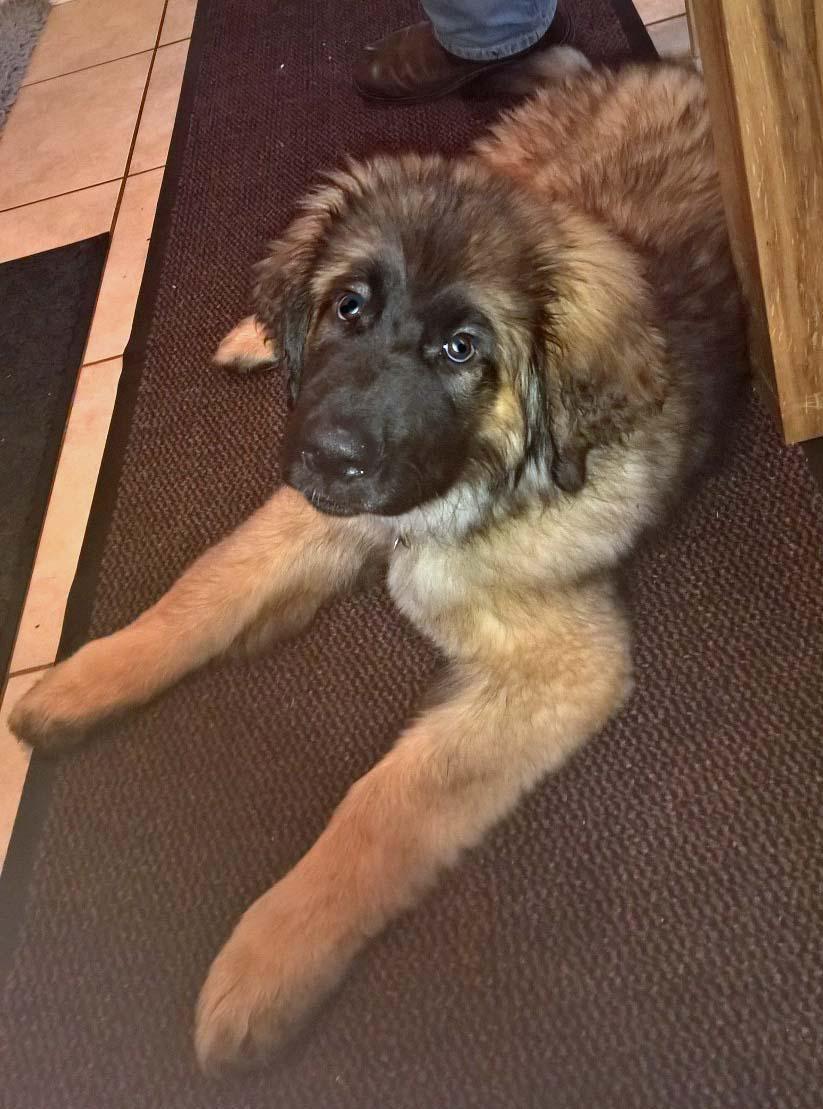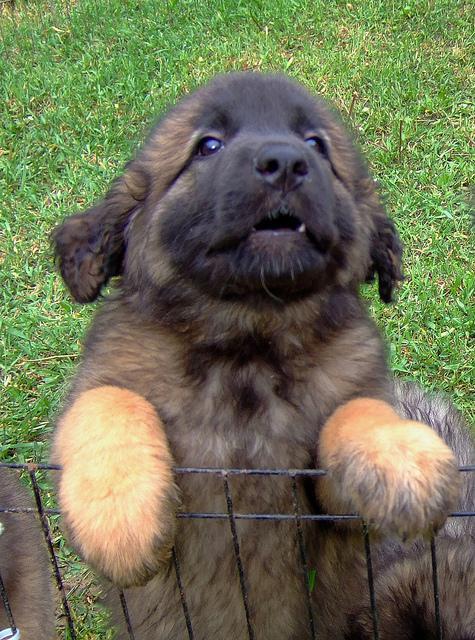The first image is the image on the left, the second image is the image on the right. Given the left and right images, does the statement "One of the dogs is laying down with its head on the floor." hold true? Answer yes or no. No. 